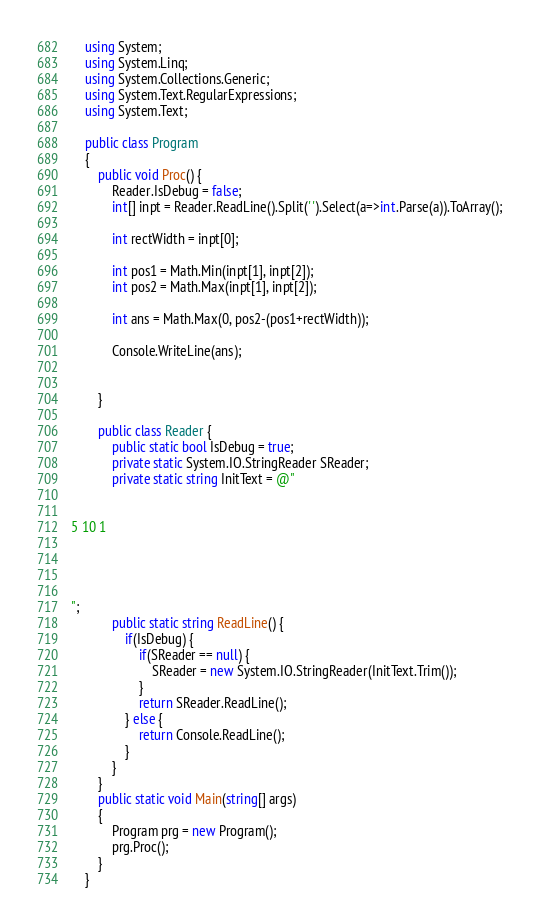<code> <loc_0><loc_0><loc_500><loc_500><_C#_>    using System;
    using System.Linq;
    using System.Collections.Generic;
    using System.Text.RegularExpressions;
    using System.Text;
     
    public class Program
    {
        public void Proc() {
            Reader.IsDebug = false;
            int[] inpt = Reader.ReadLine().Split(' ').Select(a=>int.Parse(a)).ToArray();

            int rectWidth = inpt[0];

            int pos1 = Math.Min(inpt[1], inpt[2]);
            int pos2 = Math.Max(inpt[1], inpt[2]);

            int ans = Math.Max(0, pos2-(pos1+rectWidth));

            Console.WriteLine(ans);


        }

        public class Reader {
            public static bool IsDebug = true;
            private static System.IO.StringReader SReader;
            private static string InitText = @"


5 10 1




";
            public static string ReadLine() {
                if(IsDebug) {
                    if(SReader == null) {
                        SReader = new System.IO.StringReader(InitText.Trim());
                    }
                    return SReader.ReadLine();
                } else {
                    return Console.ReadLine();
                }
            }
        }
        public static void Main(string[] args)
        {
            Program prg = new Program();
            prg.Proc();
        }
    }</code> 